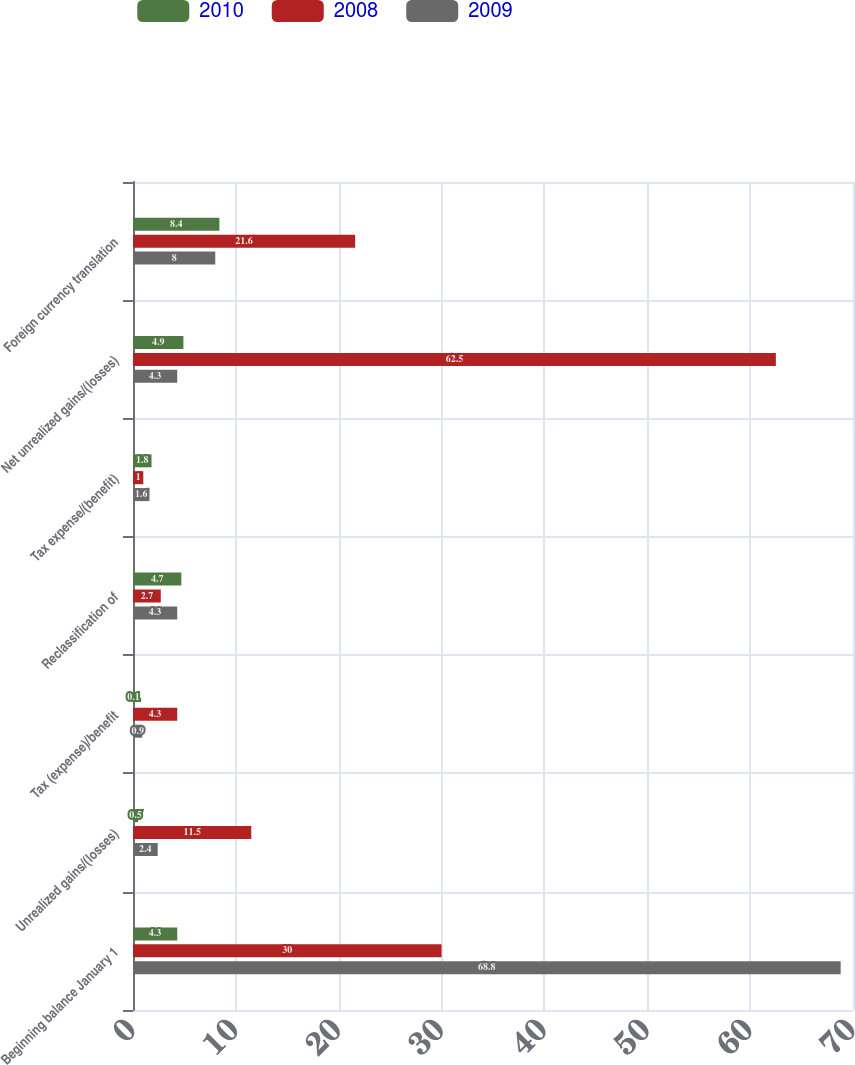Convert chart. <chart><loc_0><loc_0><loc_500><loc_500><stacked_bar_chart><ecel><fcel>Beginning balance January 1<fcel>Unrealized gains/(losses)<fcel>Tax (expense)/benefit<fcel>Reclassification of<fcel>Tax expense/(benefit)<fcel>Net unrealized gains/(losses)<fcel>Foreign currency translation<nl><fcel>2010<fcel>4.3<fcel>0.5<fcel>0.1<fcel>4.7<fcel>1.8<fcel>4.9<fcel>8.4<nl><fcel>2008<fcel>30<fcel>11.5<fcel>4.3<fcel>2.7<fcel>1<fcel>62.5<fcel>21.6<nl><fcel>2009<fcel>68.8<fcel>2.4<fcel>0.9<fcel>4.3<fcel>1.6<fcel>4.3<fcel>8<nl></chart> 